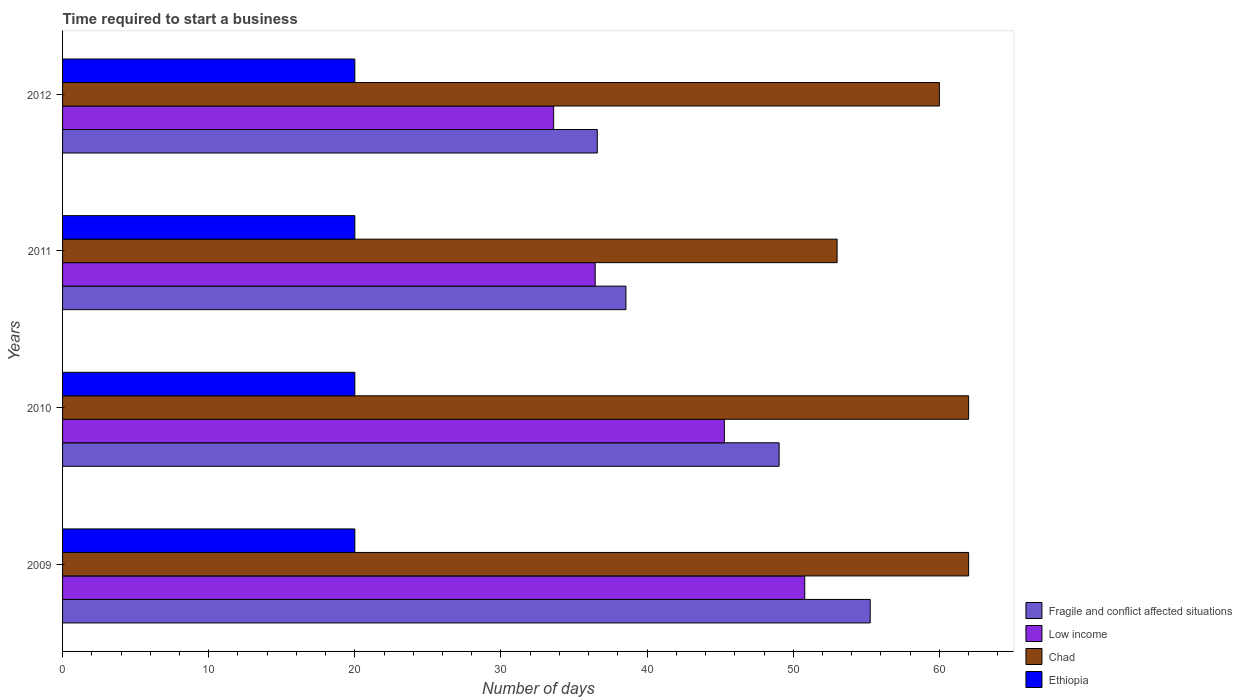Are the number of bars on each tick of the Y-axis equal?
Keep it short and to the point. Yes. In how many cases, is the number of bars for a given year not equal to the number of legend labels?
Offer a terse response. 0. What is the number of days required to start a business in Ethiopia in 2009?
Your response must be concise. 20. Across all years, what is the maximum number of days required to start a business in Chad?
Your response must be concise. 62. Across all years, what is the minimum number of days required to start a business in Chad?
Offer a very short reply. 53. In which year was the number of days required to start a business in Fragile and conflict affected situations minimum?
Keep it short and to the point. 2012. What is the total number of days required to start a business in Low income in the graph?
Offer a very short reply. 166.12. What is the difference between the number of days required to start a business in Fragile and conflict affected situations in 2010 and that in 2012?
Offer a terse response. 12.44. What is the difference between the number of days required to start a business in Low income in 2009 and the number of days required to start a business in Ethiopia in 2012?
Ensure brevity in your answer.  30.79. What is the average number of days required to start a business in Low income per year?
Your answer should be very brief. 41.53. In the year 2010, what is the difference between the number of days required to start a business in Chad and number of days required to start a business in Fragile and conflict affected situations?
Provide a short and direct response. 12.97. What is the ratio of the number of days required to start a business in Chad in 2009 to that in 2010?
Your answer should be compact. 1. Is the number of days required to start a business in Chad in 2010 less than that in 2011?
Make the answer very short. No. What is the difference between the highest and the lowest number of days required to start a business in Chad?
Your answer should be compact. 9. In how many years, is the number of days required to start a business in Fragile and conflict affected situations greater than the average number of days required to start a business in Fragile and conflict affected situations taken over all years?
Make the answer very short. 2. Is it the case that in every year, the sum of the number of days required to start a business in Chad and number of days required to start a business in Low income is greater than the sum of number of days required to start a business in Fragile and conflict affected situations and number of days required to start a business in Ethiopia?
Your answer should be compact. No. What does the 2nd bar from the top in 2010 represents?
Provide a succinct answer. Chad. What does the 3rd bar from the bottom in 2010 represents?
Offer a terse response. Chad. Are all the bars in the graph horizontal?
Offer a very short reply. Yes. What is the difference between two consecutive major ticks on the X-axis?
Your response must be concise. 10. Does the graph contain any zero values?
Ensure brevity in your answer.  No. Where does the legend appear in the graph?
Keep it short and to the point. Bottom right. How are the legend labels stacked?
Provide a short and direct response. Vertical. What is the title of the graph?
Your response must be concise. Time required to start a business. Does "Jamaica" appear as one of the legend labels in the graph?
Your response must be concise. No. What is the label or title of the X-axis?
Your answer should be compact. Number of days. What is the label or title of the Y-axis?
Your answer should be compact. Years. What is the Number of days of Fragile and conflict affected situations in 2009?
Offer a terse response. 55.27. What is the Number of days in Low income in 2009?
Offer a terse response. 50.79. What is the Number of days in Chad in 2009?
Keep it short and to the point. 62. What is the Number of days of Fragile and conflict affected situations in 2010?
Provide a short and direct response. 49.03. What is the Number of days of Low income in 2010?
Provide a short and direct response. 45.29. What is the Number of days in Chad in 2010?
Ensure brevity in your answer.  62. What is the Number of days of Ethiopia in 2010?
Give a very brief answer. 20. What is the Number of days in Fragile and conflict affected situations in 2011?
Ensure brevity in your answer.  38.55. What is the Number of days of Low income in 2011?
Give a very brief answer. 36.45. What is the Number of days in Chad in 2011?
Your response must be concise. 53. What is the Number of days of Ethiopia in 2011?
Provide a succinct answer. 20. What is the Number of days in Fragile and conflict affected situations in 2012?
Offer a very short reply. 36.59. What is the Number of days in Low income in 2012?
Ensure brevity in your answer.  33.6. Across all years, what is the maximum Number of days of Fragile and conflict affected situations?
Provide a succinct answer. 55.27. Across all years, what is the maximum Number of days of Low income?
Provide a succinct answer. 50.79. Across all years, what is the maximum Number of days of Chad?
Offer a very short reply. 62. Across all years, what is the maximum Number of days of Ethiopia?
Your response must be concise. 20. Across all years, what is the minimum Number of days in Fragile and conflict affected situations?
Your answer should be compact. 36.59. Across all years, what is the minimum Number of days of Low income?
Your answer should be very brief. 33.6. Across all years, what is the minimum Number of days in Chad?
Your answer should be very brief. 53. Across all years, what is the minimum Number of days of Ethiopia?
Offer a very short reply. 20. What is the total Number of days in Fragile and conflict affected situations in the graph?
Offer a very short reply. 179.44. What is the total Number of days of Low income in the graph?
Your response must be concise. 166.12. What is the total Number of days of Chad in the graph?
Offer a very short reply. 237. What is the difference between the Number of days of Fragile and conflict affected situations in 2009 and that in 2010?
Your response must be concise. 6.23. What is the difference between the Number of days in Low income in 2009 and that in 2010?
Offer a terse response. 5.5. What is the difference between the Number of days in Chad in 2009 and that in 2010?
Keep it short and to the point. 0. What is the difference between the Number of days of Fragile and conflict affected situations in 2009 and that in 2011?
Your answer should be very brief. 16.72. What is the difference between the Number of days in Low income in 2009 and that in 2011?
Your answer should be very brief. 14.34. What is the difference between the Number of days in Fragile and conflict affected situations in 2009 and that in 2012?
Your answer should be very brief. 18.68. What is the difference between the Number of days of Low income in 2009 and that in 2012?
Provide a short and direct response. 17.18. What is the difference between the Number of days of Chad in 2009 and that in 2012?
Your answer should be compact. 2. What is the difference between the Number of days of Fragile and conflict affected situations in 2010 and that in 2011?
Ensure brevity in your answer.  10.48. What is the difference between the Number of days of Low income in 2010 and that in 2011?
Provide a succinct answer. 8.84. What is the difference between the Number of days of Ethiopia in 2010 and that in 2011?
Ensure brevity in your answer.  0. What is the difference between the Number of days of Fragile and conflict affected situations in 2010 and that in 2012?
Offer a very short reply. 12.44. What is the difference between the Number of days in Low income in 2010 and that in 2012?
Keep it short and to the point. 11.68. What is the difference between the Number of days of Chad in 2010 and that in 2012?
Give a very brief answer. 2. What is the difference between the Number of days of Fragile and conflict affected situations in 2011 and that in 2012?
Make the answer very short. 1.96. What is the difference between the Number of days in Low income in 2011 and that in 2012?
Your response must be concise. 2.84. What is the difference between the Number of days in Ethiopia in 2011 and that in 2012?
Your answer should be compact. 0. What is the difference between the Number of days of Fragile and conflict affected situations in 2009 and the Number of days of Low income in 2010?
Provide a succinct answer. 9.98. What is the difference between the Number of days of Fragile and conflict affected situations in 2009 and the Number of days of Chad in 2010?
Keep it short and to the point. -6.73. What is the difference between the Number of days in Fragile and conflict affected situations in 2009 and the Number of days in Ethiopia in 2010?
Offer a very short reply. 35.27. What is the difference between the Number of days in Low income in 2009 and the Number of days in Chad in 2010?
Your answer should be very brief. -11.21. What is the difference between the Number of days of Low income in 2009 and the Number of days of Ethiopia in 2010?
Offer a terse response. 30.79. What is the difference between the Number of days of Fragile and conflict affected situations in 2009 and the Number of days of Low income in 2011?
Your answer should be very brief. 18.82. What is the difference between the Number of days of Fragile and conflict affected situations in 2009 and the Number of days of Chad in 2011?
Provide a succinct answer. 2.27. What is the difference between the Number of days of Fragile and conflict affected situations in 2009 and the Number of days of Ethiopia in 2011?
Give a very brief answer. 35.27. What is the difference between the Number of days of Low income in 2009 and the Number of days of Chad in 2011?
Your answer should be compact. -2.21. What is the difference between the Number of days in Low income in 2009 and the Number of days in Ethiopia in 2011?
Your response must be concise. 30.79. What is the difference between the Number of days in Fragile and conflict affected situations in 2009 and the Number of days in Low income in 2012?
Your response must be concise. 21.66. What is the difference between the Number of days in Fragile and conflict affected situations in 2009 and the Number of days in Chad in 2012?
Make the answer very short. -4.73. What is the difference between the Number of days in Fragile and conflict affected situations in 2009 and the Number of days in Ethiopia in 2012?
Provide a short and direct response. 35.27. What is the difference between the Number of days in Low income in 2009 and the Number of days in Chad in 2012?
Your response must be concise. -9.21. What is the difference between the Number of days in Low income in 2009 and the Number of days in Ethiopia in 2012?
Your answer should be compact. 30.79. What is the difference between the Number of days in Fragile and conflict affected situations in 2010 and the Number of days in Low income in 2011?
Provide a short and direct response. 12.59. What is the difference between the Number of days in Fragile and conflict affected situations in 2010 and the Number of days in Chad in 2011?
Keep it short and to the point. -3.97. What is the difference between the Number of days in Fragile and conflict affected situations in 2010 and the Number of days in Ethiopia in 2011?
Give a very brief answer. 29.03. What is the difference between the Number of days of Low income in 2010 and the Number of days of Chad in 2011?
Provide a succinct answer. -7.71. What is the difference between the Number of days of Low income in 2010 and the Number of days of Ethiopia in 2011?
Provide a short and direct response. 25.29. What is the difference between the Number of days of Chad in 2010 and the Number of days of Ethiopia in 2011?
Give a very brief answer. 42. What is the difference between the Number of days of Fragile and conflict affected situations in 2010 and the Number of days of Low income in 2012?
Your answer should be compact. 15.43. What is the difference between the Number of days of Fragile and conflict affected situations in 2010 and the Number of days of Chad in 2012?
Ensure brevity in your answer.  -10.97. What is the difference between the Number of days in Fragile and conflict affected situations in 2010 and the Number of days in Ethiopia in 2012?
Keep it short and to the point. 29.03. What is the difference between the Number of days of Low income in 2010 and the Number of days of Chad in 2012?
Make the answer very short. -14.71. What is the difference between the Number of days of Low income in 2010 and the Number of days of Ethiopia in 2012?
Provide a succinct answer. 25.29. What is the difference between the Number of days of Chad in 2010 and the Number of days of Ethiopia in 2012?
Offer a terse response. 42. What is the difference between the Number of days of Fragile and conflict affected situations in 2011 and the Number of days of Low income in 2012?
Provide a short and direct response. 4.95. What is the difference between the Number of days of Fragile and conflict affected situations in 2011 and the Number of days of Chad in 2012?
Provide a succinct answer. -21.45. What is the difference between the Number of days in Fragile and conflict affected situations in 2011 and the Number of days in Ethiopia in 2012?
Keep it short and to the point. 18.55. What is the difference between the Number of days in Low income in 2011 and the Number of days in Chad in 2012?
Ensure brevity in your answer.  -23.55. What is the difference between the Number of days of Low income in 2011 and the Number of days of Ethiopia in 2012?
Offer a terse response. 16.45. What is the average Number of days in Fragile and conflict affected situations per year?
Keep it short and to the point. 44.86. What is the average Number of days of Low income per year?
Ensure brevity in your answer.  41.53. What is the average Number of days in Chad per year?
Make the answer very short. 59.25. What is the average Number of days of Ethiopia per year?
Ensure brevity in your answer.  20. In the year 2009, what is the difference between the Number of days in Fragile and conflict affected situations and Number of days in Low income?
Make the answer very short. 4.48. In the year 2009, what is the difference between the Number of days in Fragile and conflict affected situations and Number of days in Chad?
Provide a succinct answer. -6.73. In the year 2009, what is the difference between the Number of days of Fragile and conflict affected situations and Number of days of Ethiopia?
Your answer should be very brief. 35.27. In the year 2009, what is the difference between the Number of days of Low income and Number of days of Chad?
Give a very brief answer. -11.21. In the year 2009, what is the difference between the Number of days of Low income and Number of days of Ethiopia?
Provide a succinct answer. 30.79. In the year 2010, what is the difference between the Number of days of Fragile and conflict affected situations and Number of days of Low income?
Offer a very short reply. 3.75. In the year 2010, what is the difference between the Number of days in Fragile and conflict affected situations and Number of days in Chad?
Provide a succinct answer. -12.97. In the year 2010, what is the difference between the Number of days of Fragile and conflict affected situations and Number of days of Ethiopia?
Make the answer very short. 29.03. In the year 2010, what is the difference between the Number of days of Low income and Number of days of Chad?
Offer a very short reply. -16.71. In the year 2010, what is the difference between the Number of days in Low income and Number of days in Ethiopia?
Provide a succinct answer. 25.29. In the year 2010, what is the difference between the Number of days in Chad and Number of days in Ethiopia?
Your answer should be very brief. 42. In the year 2011, what is the difference between the Number of days in Fragile and conflict affected situations and Number of days in Low income?
Provide a succinct answer. 2.1. In the year 2011, what is the difference between the Number of days of Fragile and conflict affected situations and Number of days of Chad?
Your answer should be compact. -14.45. In the year 2011, what is the difference between the Number of days in Fragile and conflict affected situations and Number of days in Ethiopia?
Offer a terse response. 18.55. In the year 2011, what is the difference between the Number of days in Low income and Number of days in Chad?
Your answer should be very brief. -16.55. In the year 2011, what is the difference between the Number of days in Low income and Number of days in Ethiopia?
Your answer should be compact. 16.45. In the year 2011, what is the difference between the Number of days in Chad and Number of days in Ethiopia?
Offer a terse response. 33. In the year 2012, what is the difference between the Number of days in Fragile and conflict affected situations and Number of days in Low income?
Offer a very short reply. 2.99. In the year 2012, what is the difference between the Number of days in Fragile and conflict affected situations and Number of days in Chad?
Give a very brief answer. -23.41. In the year 2012, what is the difference between the Number of days of Fragile and conflict affected situations and Number of days of Ethiopia?
Offer a very short reply. 16.59. In the year 2012, what is the difference between the Number of days in Low income and Number of days in Chad?
Make the answer very short. -26.4. In the year 2012, what is the difference between the Number of days of Low income and Number of days of Ethiopia?
Offer a terse response. 13.6. What is the ratio of the Number of days of Fragile and conflict affected situations in 2009 to that in 2010?
Your answer should be very brief. 1.13. What is the ratio of the Number of days of Low income in 2009 to that in 2010?
Your answer should be very brief. 1.12. What is the ratio of the Number of days of Ethiopia in 2009 to that in 2010?
Provide a succinct answer. 1. What is the ratio of the Number of days of Fragile and conflict affected situations in 2009 to that in 2011?
Your response must be concise. 1.43. What is the ratio of the Number of days of Low income in 2009 to that in 2011?
Offer a terse response. 1.39. What is the ratio of the Number of days in Chad in 2009 to that in 2011?
Provide a short and direct response. 1.17. What is the ratio of the Number of days of Ethiopia in 2009 to that in 2011?
Provide a short and direct response. 1. What is the ratio of the Number of days of Fragile and conflict affected situations in 2009 to that in 2012?
Provide a short and direct response. 1.51. What is the ratio of the Number of days of Low income in 2009 to that in 2012?
Provide a short and direct response. 1.51. What is the ratio of the Number of days of Chad in 2009 to that in 2012?
Give a very brief answer. 1.03. What is the ratio of the Number of days in Fragile and conflict affected situations in 2010 to that in 2011?
Offer a terse response. 1.27. What is the ratio of the Number of days in Low income in 2010 to that in 2011?
Your answer should be compact. 1.24. What is the ratio of the Number of days of Chad in 2010 to that in 2011?
Your response must be concise. 1.17. What is the ratio of the Number of days of Fragile and conflict affected situations in 2010 to that in 2012?
Ensure brevity in your answer.  1.34. What is the ratio of the Number of days of Low income in 2010 to that in 2012?
Your answer should be compact. 1.35. What is the ratio of the Number of days in Ethiopia in 2010 to that in 2012?
Ensure brevity in your answer.  1. What is the ratio of the Number of days in Fragile and conflict affected situations in 2011 to that in 2012?
Make the answer very short. 1.05. What is the ratio of the Number of days in Low income in 2011 to that in 2012?
Provide a short and direct response. 1.08. What is the ratio of the Number of days in Chad in 2011 to that in 2012?
Keep it short and to the point. 0.88. What is the ratio of the Number of days of Ethiopia in 2011 to that in 2012?
Ensure brevity in your answer.  1. What is the difference between the highest and the second highest Number of days of Fragile and conflict affected situations?
Your response must be concise. 6.23. What is the difference between the highest and the second highest Number of days of Low income?
Your answer should be compact. 5.5. What is the difference between the highest and the lowest Number of days of Fragile and conflict affected situations?
Keep it short and to the point. 18.68. What is the difference between the highest and the lowest Number of days in Low income?
Offer a terse response. 17.18. What is the difference between the highest and the lowest Number of days of Ethiopia?
Your answer should be compact. 0. 